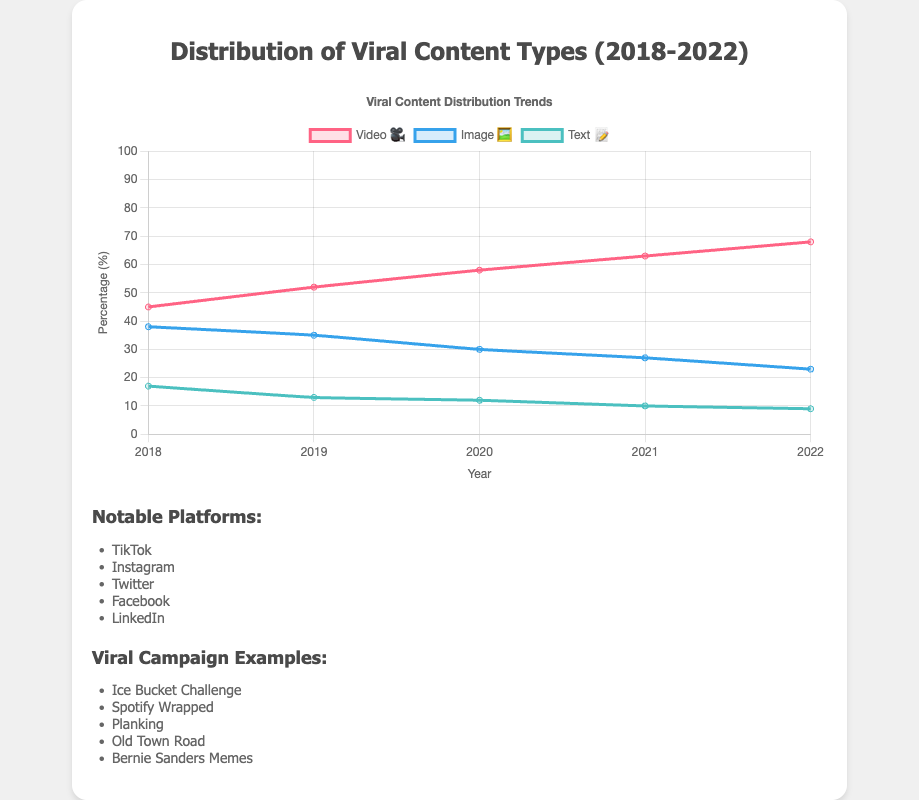What's the title of the chart? The title of the chart is displayed at the top, which reads "Distribution of Viral Content Types (2018-2022)."
Answer: Distribution of Viral Content Types (2018-2022) Which content type had the highest percentage in 2018? In 2018, the content type with the highest percentage is video, represented by the 🎥 emoji, with 45%.
Answer: Video How many years are represented in the chart? The x-axis of the chart lists the years from 2018 to 2022, which means five years are represented.
Answer: 5 What was the percentage difference between video and text content in 2022? In 2022, the percentage for video was 68% and for text it was 9%. The difference is calculated as 68 - 9.
Answer: 59 Which content type showed a decreasing trend over the years? The line representing image content (🖼️) shows a downward slope from 38% in 2018 to 23% in 2022, indicating a decreasing trend.
Answer: Image Between 2019 and 2020, which content type saw the largest increase? Between 2019 and 2020, video content (🎥) increased from 52% to 58%, a growth of 6%, which is the largest increase compared to image (3%) and text (1%).
Answer: Video What is the approximate slope of the trend line for text content (📝) over the period? The text content percentage decreases from 17% in 2018 to 9% in 2022 over a span of 5 years. The slope can be approximated as (9 - 17)/(2022 - 2018) = -8/4, which simplifies to -2.
Answer: -2 Which year had the closest percentages for image and text content? In 2022, the difference between image (23%) and text (9%) was 14%, which is closer compared to other years where the differences were larger.
Answer: 2022 What specific trend do we see in video content from 2018-2022? The trend for video content shows a consistent increase each year, starting at 45% in 2018 and rising to 68% in 2022.
Answer: Consistent Increase By how much did the percentage of image content drop from 2018 to 2022? The image content percentage in 2018 was 38%, and it dropped to 23% in 2022. Therefore, the drop is calculated as 38 - 23.
Answer: 15 Which content type had the smallest change in percentage points from 2018 to 2022? Text content had the smallest change, going from 17% in 2018 to 9% in 2022, which is a difference of 8 percentage points compared to video (23 points) and image (15 points).
Answer: Text 